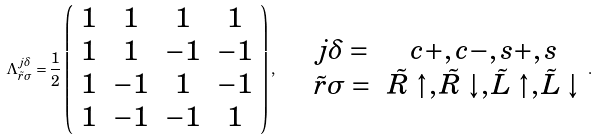Convert formula to latex. <formula><loc_0><loc_0><loc_500><loc_500>\Lambda _ { \tilde { r } \sigma } ^ { j \delta } = \frac { 1 } { 2 } \left ( \begin{array} { c c c c } 1 & 1 & 1 & 1 \\ 1 & 1 & - 1 & - 1 \\ 1 & - 1 & 1 & - 1 \\ 1 & - 1 & - 1 & 1 \end{array} \right ) , \quad \begin{array} { c c } j \delta = & c + , c - , s + , s \\ \tilde { r } \sigma = & \tilde { R } \uparrow , \tilde { R } \downarrow , \tilde { L } \uparrow , \tilde { L } \downarrow \end{array} .</formula> 